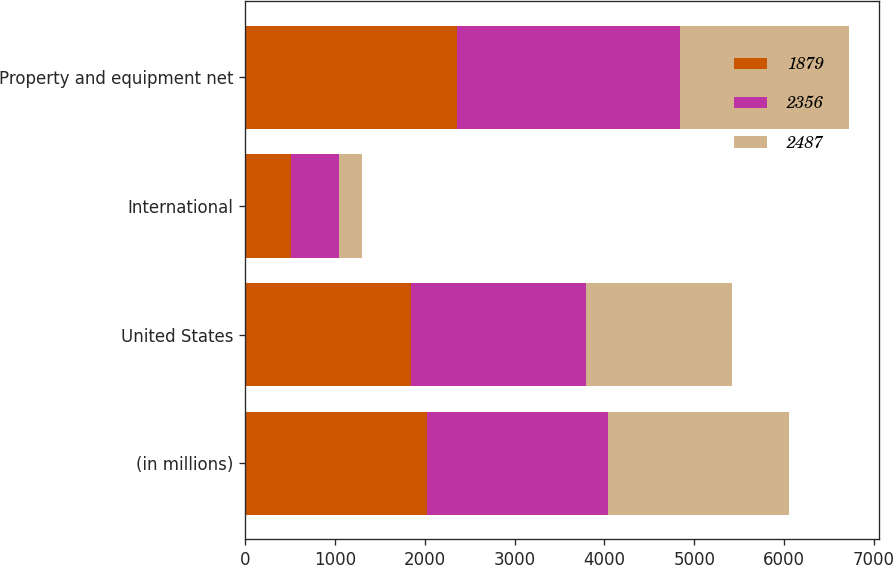<chart> <loc_0><loc_0><loc_500><loc_500><stacked_bar_chart><ecel><fcel>(in millions)<fcel>United States<fcel>International<fcel>Property and equipment net<nl><fcel>1879<fcel>2019<fcel>1846<fcel>510<fcel>2356<nl><fcel>2356<fcel>2018<fcel>1950<fcel>537<fcel>2487<nl><fcel>2487<fcel>2017<fcel>1623<fcel>256<fcel>1879<nl></chart> 